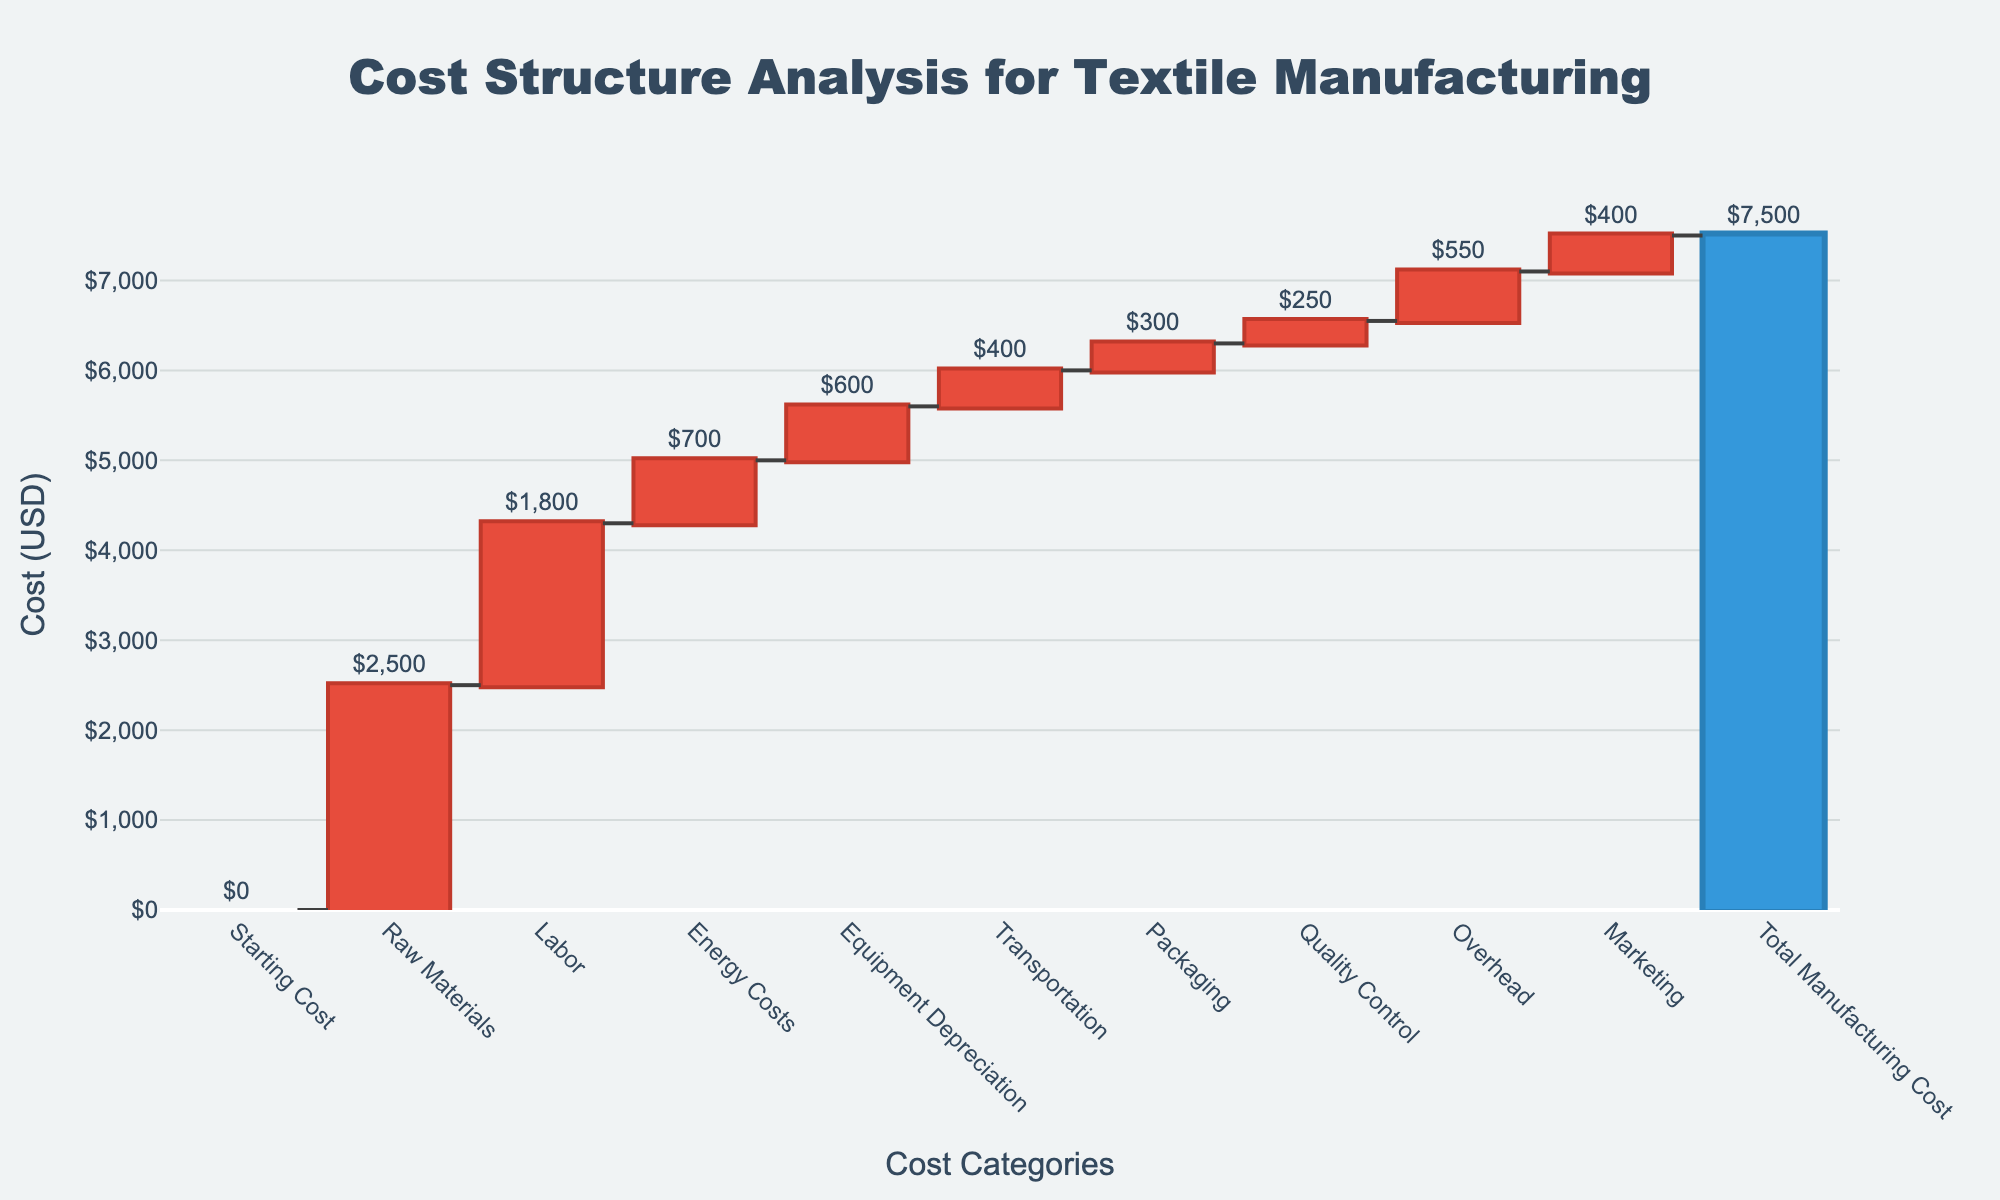What is the title of the figure? The title is located at the top of the figure, and it provides a brief description of what the chart represents.
Answer: Cost Structure Analysis for Textile Manufacturing What is the value of the raw materials? The value of each category is labeled right outside each bar. The value for raw materials specifically is labeled as $2,500.
Answer: $2,500 Which cost category has the lowest value? By examining the values labeled outside each bar, Quality Control has the lowest value labeled as $250.
Answer: Quality Control What is the total manufacturing cost? The total value is shown at the end of the chart, labeled as "Total Manufacturing Cost" with a value of $7,500.
Answer: $7,500 How much do raw materials and labor cost in total? The cost of raw materials is $2,500 and labor is $1,800. Summing these values: $2,500 + $1,800 = $4,300.
Answer: $4,300 What is the difference between labor costs and transportation costs? The cost of labor is $1,800 and transportation is $400. Subtracting these values: $1,800 - $400 = $1,400.
Answer: $1,400 How do energy costs compare to packaging costs? Energy costs are $700 and packaging costs are $300. Energy costs are greater than packaging costs by $700 - $300 = $400.
Answer: Energy costs are $400 greater than packaging costs What is the average cost of equipment depreciation, transportation, and packaging? Summing the costs: $600 + $400 + $300 = $1,300. The number of categories is 3. The average is $1,300 / 3 = approximately $433.33.
Answer: Approximately $433.33 How much more are overhead costs compared to quality control costs? Overhead costs are $550 and quality control costs are $250. The difference is $550 - $250 = $300.
Answer: $300 What are the two categories with the highest costs? By inspecting the values for each category, raw materials ($2,500) and labor ($1,800) are the highest costs.
Answer: Raw Materials and Labor 